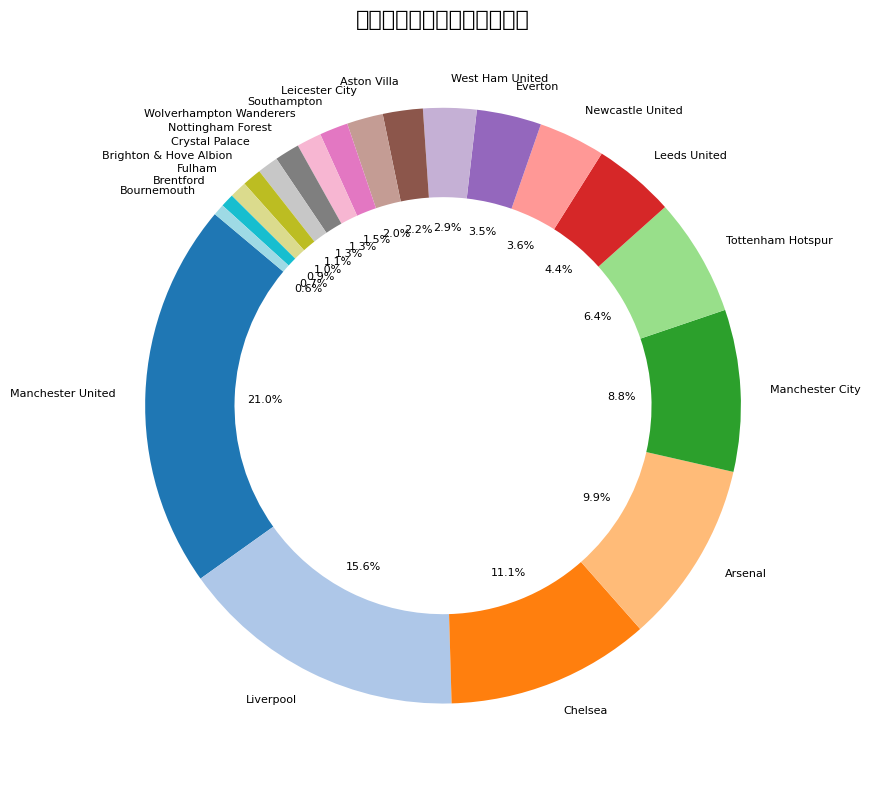哪个球队拥有最高的支持比例？ 图表中曼联足球俱乐部的支持比例占比最大，为20.3%。因此，曼联拥有最高的支持比例。
Answer: 曼联 利物浦和切尔西的支持比例之和是多少？ 根据图表，利物浦的支持比例为15.1%，切尔西的支持比例为10.7%。通过相加，可以得到它们的总支持比例：15.1% + 10.7% = 25.8%。
Answer: 25.8% 哪个球队的支持比例比阿森纳多但比利物浦少？ 从图表中可以看到，曼联和利物浦的支持比例超过阿森纳，但切尔西的支持比例为10.7%，即比阿森纳多但比利物浦少。
Answer: 切尔西 哪个球队的支持比例最小？ 图表显示伯恩茅斯俱乐部的支持比例为0.6%，是所有球队中最小的支持比例。
Answer: 伯恩茅斯 支持比例超过10%的球队有几个？ 从图表可以看出，支持比例超过10%的球队有三个，分别是曼联、利物浦和切尔西。
Answer: 3个 若将3%以上支持比例的球队的支持比例相加，会得出多少？ 根据图表，支持比例为3%以上的球队有曼联(20.3%)、利物浦(15.1%)、切尔西(10.7%)、阿森纳(9.6%)、曼城(8.5%)、热刺(6.2%)、利兹联(4.3%)、纽卡斯尔联(3.5%)、埃弗顿(3.4%)。将这些比例相加得出：(20.3 + 15.1 + 10.7 + 9.6 + 8.5 + 6.2 + 4.3 + 3.5 + 3.4) = 81.6%
Answer: 81.6% 曼城和热刺的支持比例差是多少？ 曼城的支持比例为8.5%，热刺的支持比例为6.2%。通过计算它们的差异，可以得出：8.5% - 6.2% = 2.3%。
Answer: 2.3% 排名前三的球队占总支持比例的百分比是多少？ 排名前三的球队是曼联(20.3%)、利物浦(15.1%)和切尔西(10.7%)。将它们的支持比例相加得出：(20.3 + 15.1 + 10.7) = 46.1%。
Answer: 46.1% 支持比例为1.5%的球队是什么颜色？ 图表中，南安普敦足球俱乐部的支持比例为1.5%。可以直接查看图中该部分的颜色。
Answer: (参考图表颜色) 